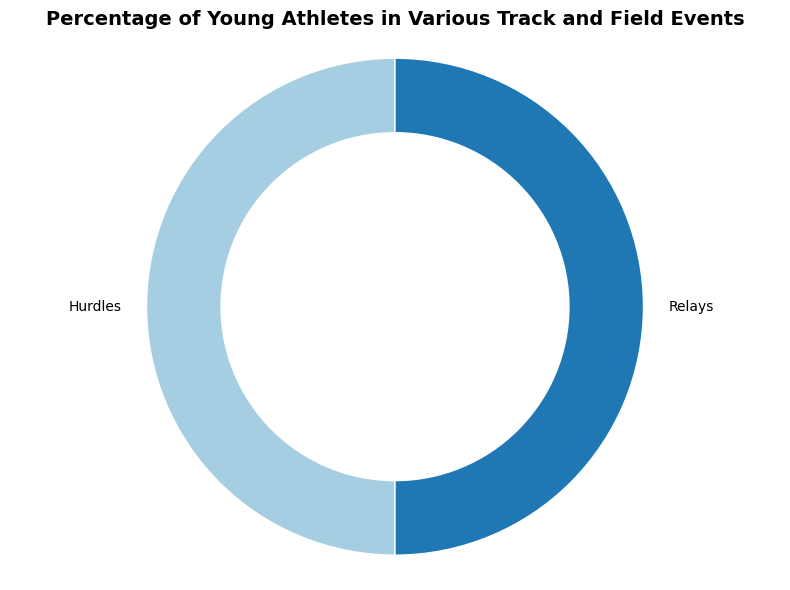What percentage of young athletes is represented by Hurdles and Relays combined? First, identify the percentages for both Hurdles (10%) and Relays (10%). Then add these percentages together: 10% + 10% = 20%.
Answer: 20% Which event has a higher percentage of young athletes, Hurdles or Relays? Both events are labeled with their percentages. The figure shows that both Hurdles and Relays have the same percentage of young athletes (10%), hence neither is higher than the other.
Answer: Neither What is the visual style used to distinguish the portions representing Hurdles and Relays in the pie chart? The pie chart uses colors to differentiate between the events. Each event's segment has a distinct color, ensuring clarity in representation.
Answer: Distinct colors What fraction of the pie chart is taken up by Hurdles? Since the pie chart represents the entire dataset as 100% and the percentage for Hurdles is 10%, the fraction of the pie chart for Hurdles is 10/100, which simplifies to 1/10.
Answer: 1/10 Considering the information in the figure, how would the pie chart change if the percentage for Hurdles increased to 20% while the total remains 100%? If Hurdles increased to 20%, the segment representing Hurdles would visually expand, occupying a larger portion of the pie chart. As the total must remain 100%, other segments (if present) would be adjusted accordingly. However, since only Hurdles and Relays are mentioned, the remaining 80% would have to be distributed elsewhere or removed.
Answer: Hurdles segment expands By looking at the pie chart, how are the inner sections of the pie slices visually connected to their labels? The pie chart uses lines (leader lines or connectors) connecting the segments to their labels for clear identification, ensuring that each event's percentage and name are easily associated with its visual representation.
Answer: Lines 